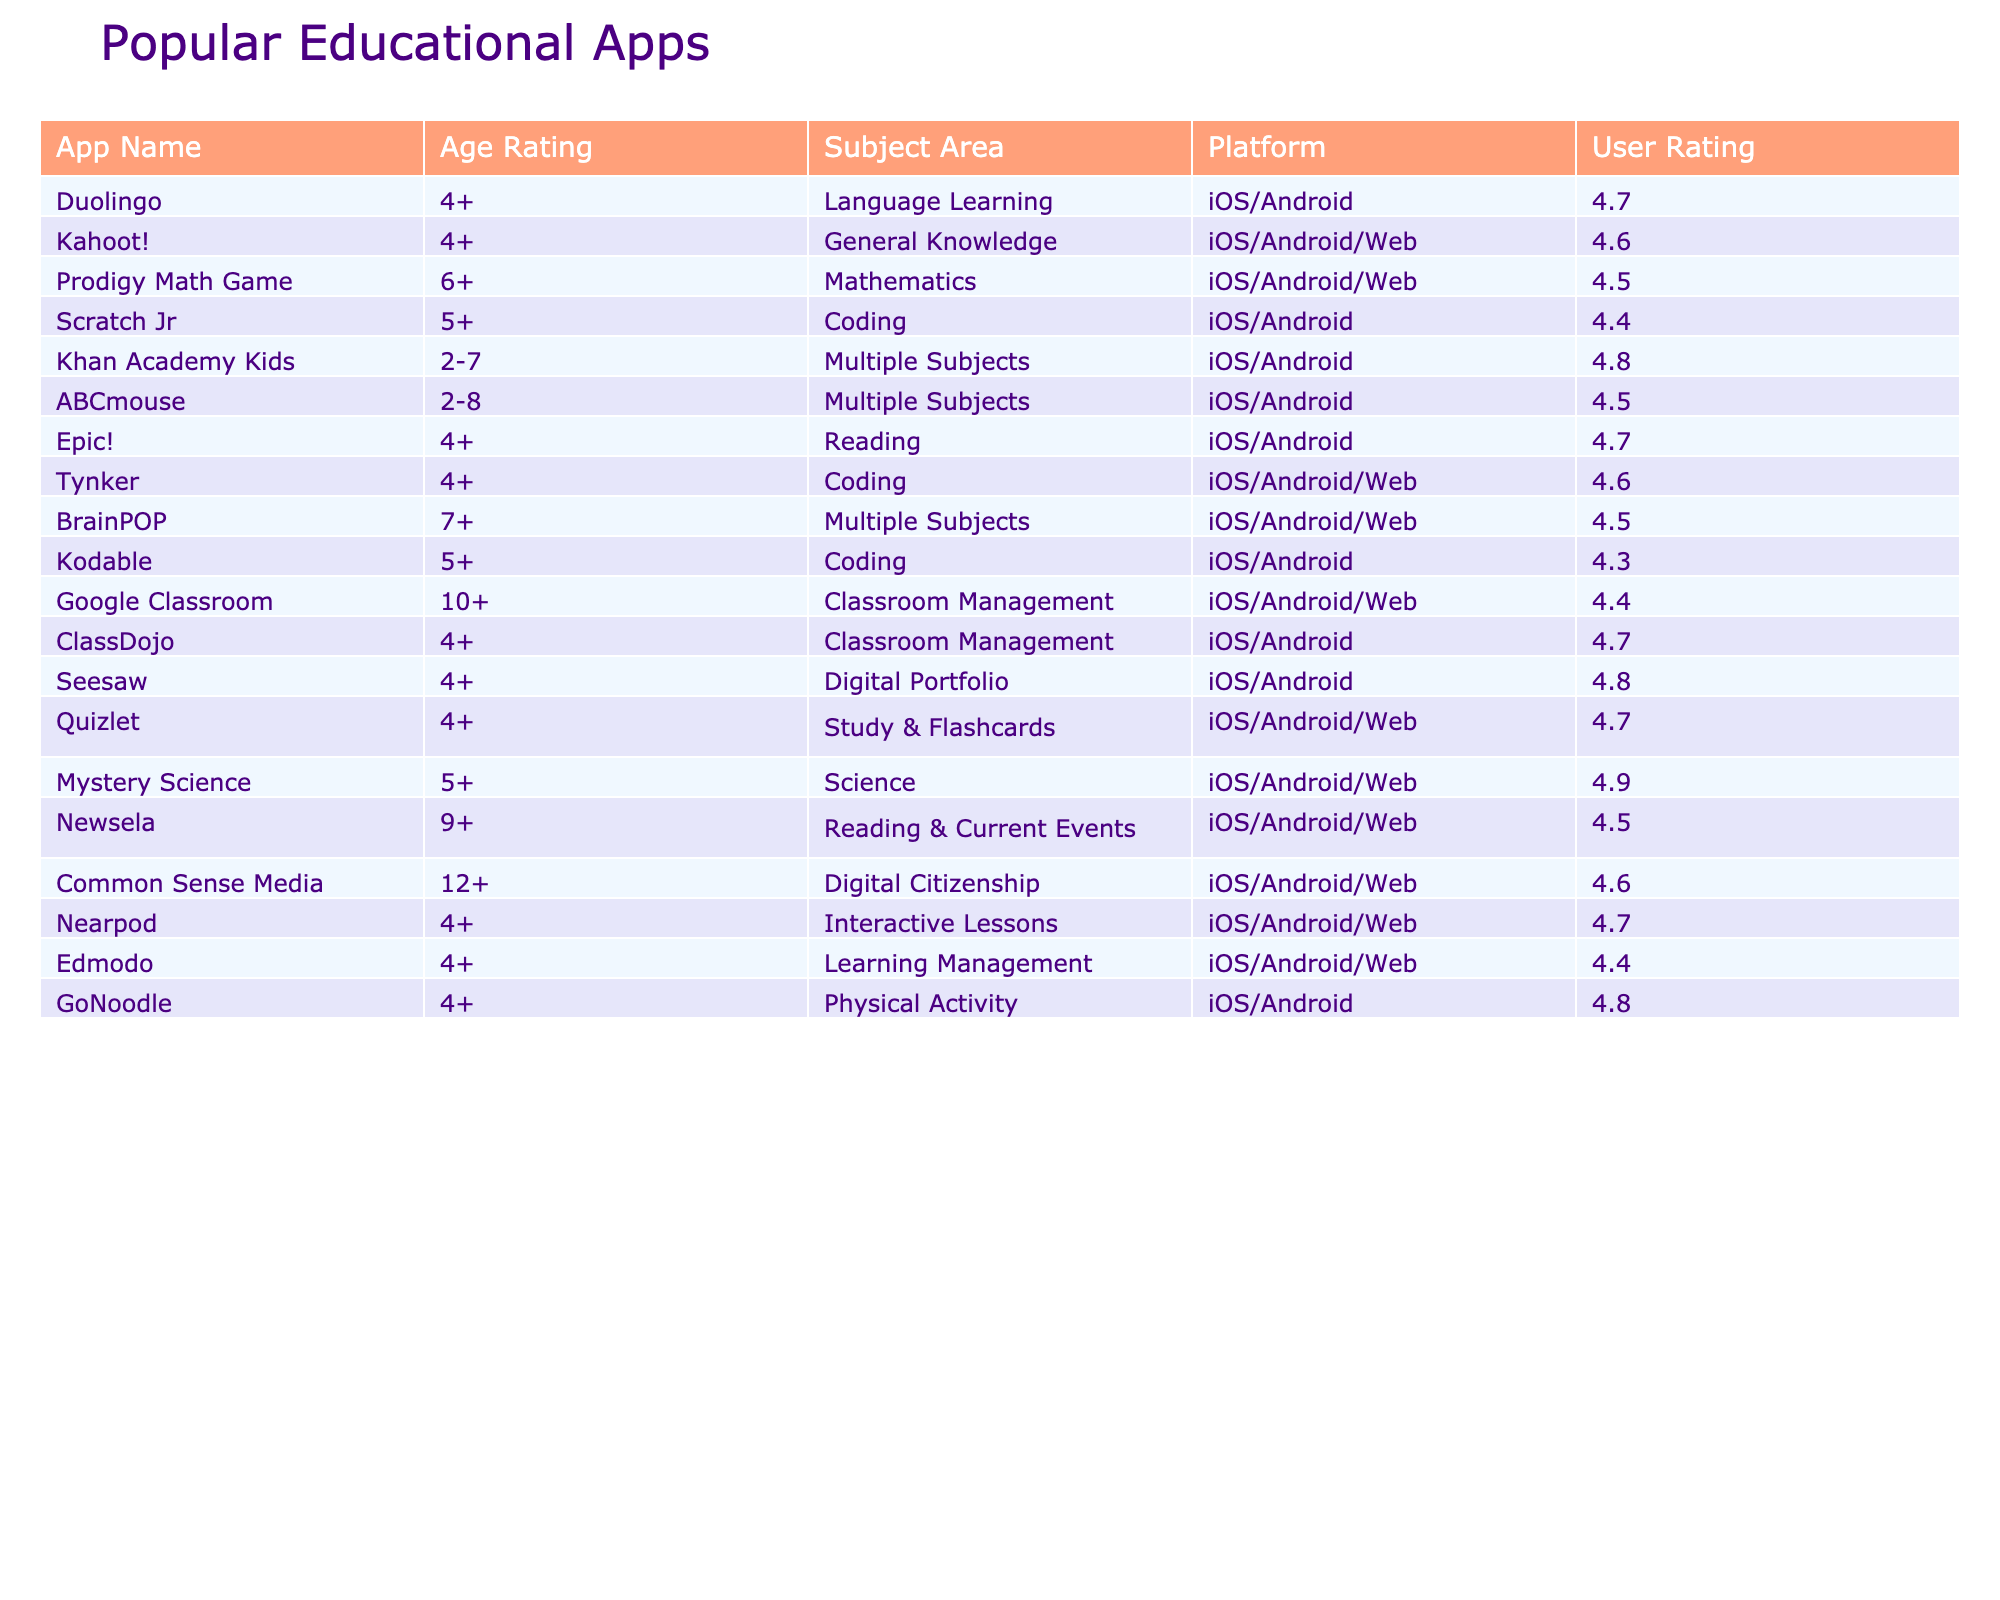What is the age rating for "Kahoot!"? "Kahoot!" has an age rating of 4+. You can find this directly in the table under the Age Rating column for "Kahoot!".
Answer: 4+ Which app has the highest user rating? By examining the User Rating column, "Mystery Science" has a user rating of 4.9, which is the highest among all the apps listed.
Answer: 4.9 How many apps are rated for ages 4 and up? Count the apps that have an age rating of 4+ or higher, which are: Duolingo, Kahoot!, Prodigy Math Game, Scratch Jr, Epic!, Tynker, ClassDojo, Seesaw, Quizlet, Nearpod, Edmodo, and GoNoodle. This totals 12 apps.
Answer: 12 Is "Google Classroom" suitable for children under 10? "Google Classroom" has an age rating of 10+, which means it is not suitable for children under 10 years old. This is evident in the Age Rating column.
Answer: No What is the average user rating for apps with the age rating 4+? The user ratings for apps with an age rating of 4+ are 4.7 (Duolingo), 4.6 (Kahoot!), 4.5 (Prodigy Math Game), 4.4 (Scratch Jr), 4.7 (Epic!), 4.6 (Tynker), 4.7 (ClassDojo), 4.8 (Seesaw), 4.7 (Quizlet), 4.7 (Nearpod), 4.4 (Edmodo), and 4.8 (GoNoodle). We add these ratings (4.7 + 4.6 + 4.5 + 4.4 + 4.7 + 4.6 + 4.7 + 4.8 + 4.7 + 4.4 + 4.8) which equals 52.6, and then divide by 12 (number of apps) to find the average, which is approximately 4.38.
Answer: 4.38 Which subject area does "ABCmouse" belong to? Looking at the Subject Area column, "ABCmouse" is categorized under Multiple Subjects. This information is directly provided in the table.
Answer: Multiple Subjects How many apps are there for coding that have an age rating of 5 or older? The apps for coding with age ratings of 5 or higher are "Scratch Jr" (5+), "Kodable" (5+), and "Tynker" (4+). However, only "Scratch Jr" and "Kodable" meet the requirement of at least 5+. Therefore, there are 2 apps.
Answer: 2 Are there any apps that focus on digital citizenship for kids under 12? The only app related to digital citizenship is "Common Sense Media," which has an age rating of 12+. Therefore, there are no apps focused on digital citizenship for children under 12.
Answer: No What is the difference between the user ratings of "Kahoot!" and "Kodable"? The user ratings for "Kahoot!" is 4.6 and for "Kodable" is 4.3. The difference is 4.6 - 4.3 = 0.3.
Answer: 0.3 Which app would you recommend for children aged 2-7? "Khan Academy Kids" is rated for ages 2-7 and offers multiple subjects, making it suitable for that age group. The table provides this specific information under the Age Rating and Subject Area columns.
Answer: Khan Academy Kids How many apps fall under the category of "Reading"? The apps that fall under the "Reading" category are "Epic!" and "Newsela". Counting these gives us a total of 2 apps in the Reading category.
Answer: 2 